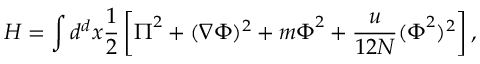<formula> <loc_0><loc_0><loc_500><loc_500>H = \int d ^ { d } x \frac { 1 } { 2 } \left [ \Pi ^ { 2 } + ( \nabla \Phi ) ^ { 2 } + m \Phi ^ { 2 } + \frac { u } { 1 2 N } ( \Phi ^ { 2 } ) ^ { 2 } \right ] ,</formula> 